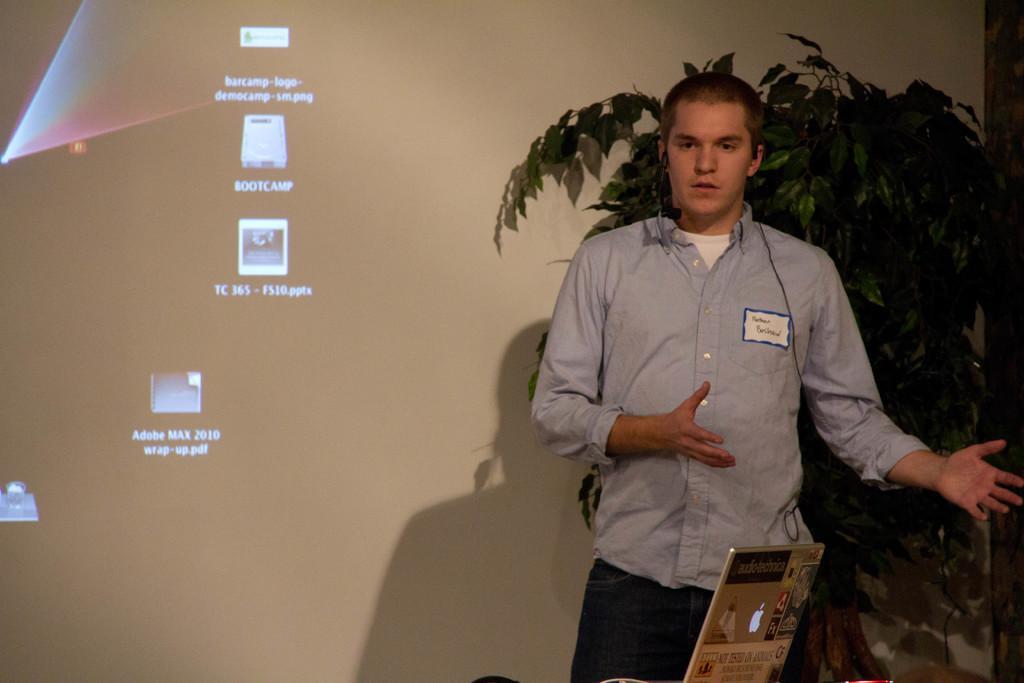Please provide a concise description of this image. In this image we can see a man is standing, he is wearing the blue shirt, at the back there is a plant, there is laptop on the table, there is a screen. 